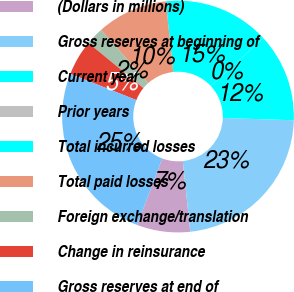<chart> <loc_0><loc_0><loc_500><loc_500><pie_chart><fcel>(Dollars in millions)<fcel>Gross reserves at beginning of<fcel>Current year<fcel>Prior years<fcel>Total incurred losses<fcel>Total paid losses<fcel>Foreign exchange/translation<fcel>Change in reinsurance<fcel>Gross reserves at end of<nl><fcel>7.42%<fcel>22.8%<fcel>12.36%<fcel>0.01%<fcel>14.83%<fcel>9.89%<fcel>2.48%<fcel>4.95%<fcel>25.27%<nl></chart> 